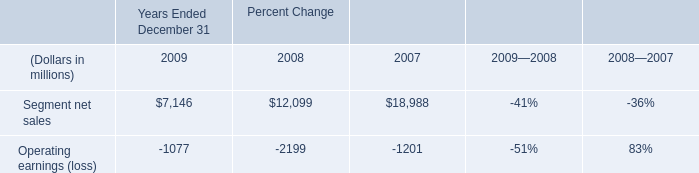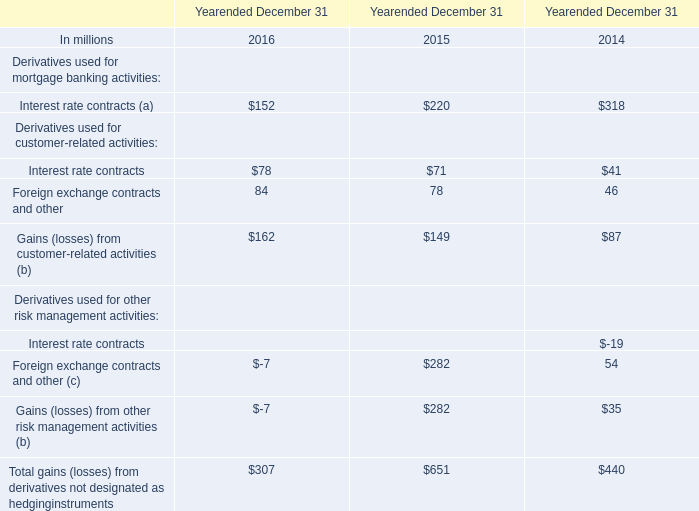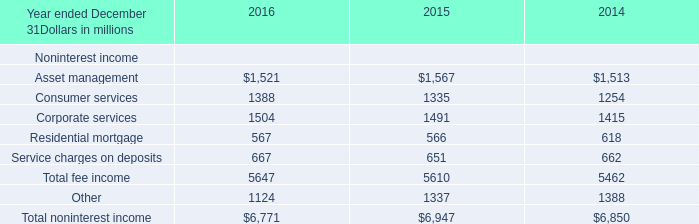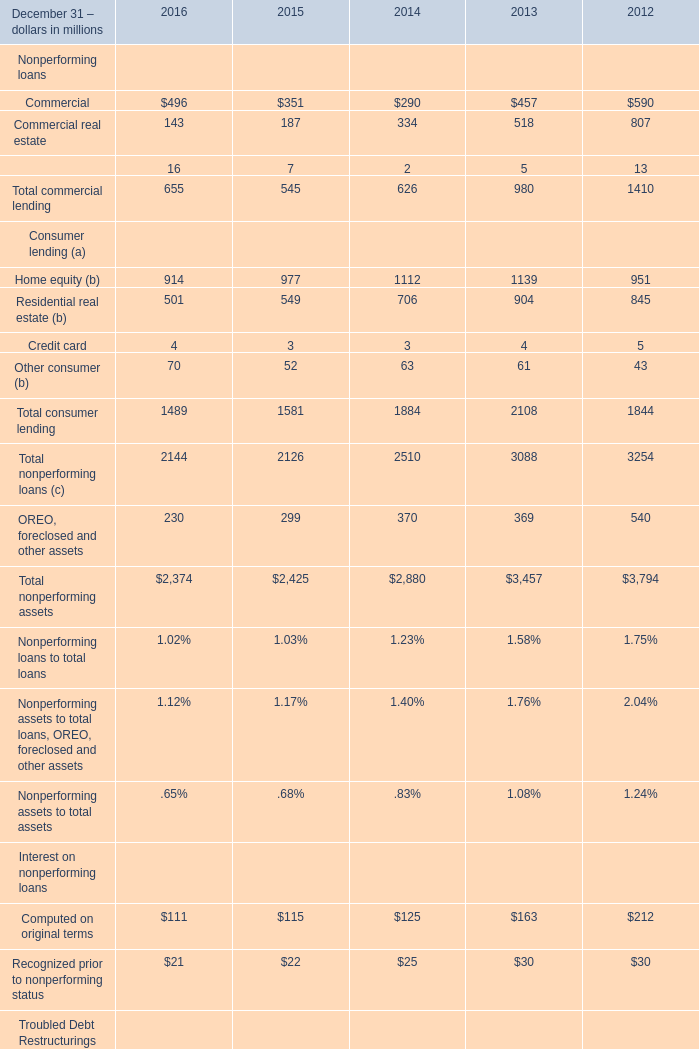What is the average amount of Corporate services of 2016, and Nonperforming Troubled Debt Restructurings of 2013 ? 
Computations: ((1504.0 + 1511.0) / 2)
Answer: 1507.5. 